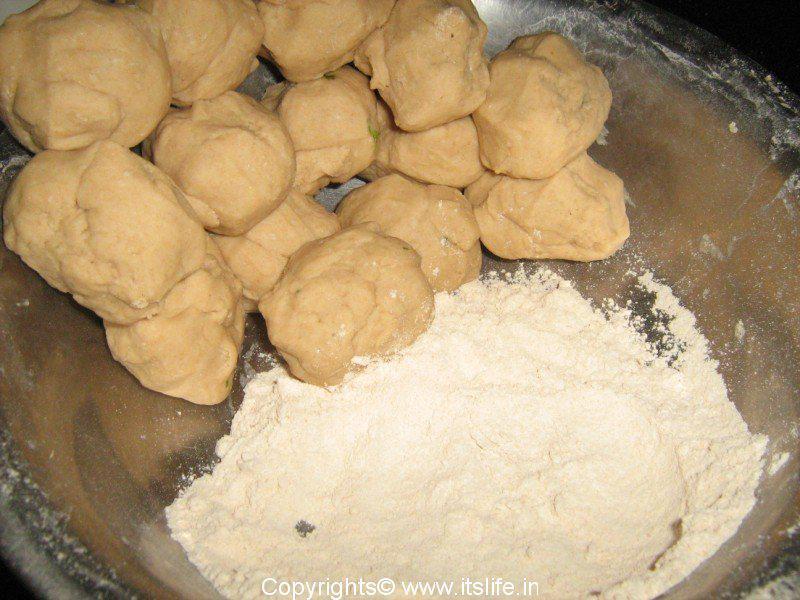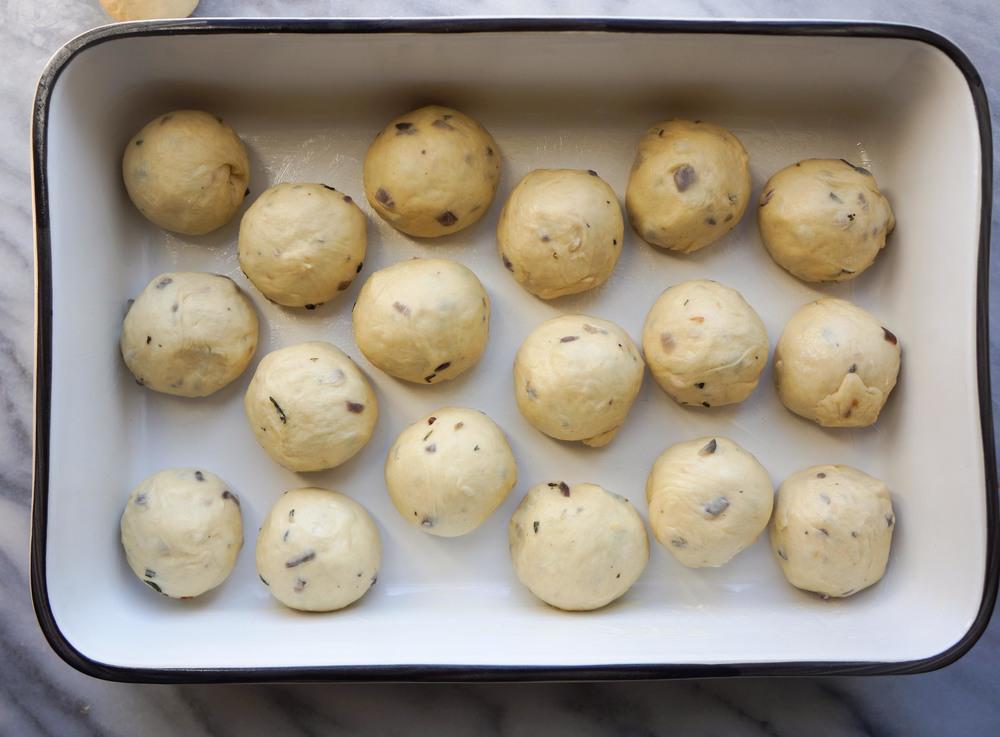The first image is the image on the left, the second image is the image on the right. Examine the images to the left and right. Is the description "In at least one image a person's hand has wet dough stretching down." accurate? Answer yes or no. No. The first image is the image on the left, the second image is the image on the right. Analyze the images presented: Is the assertion "A person is lifting dough." valid? Answer yes or no. No. 